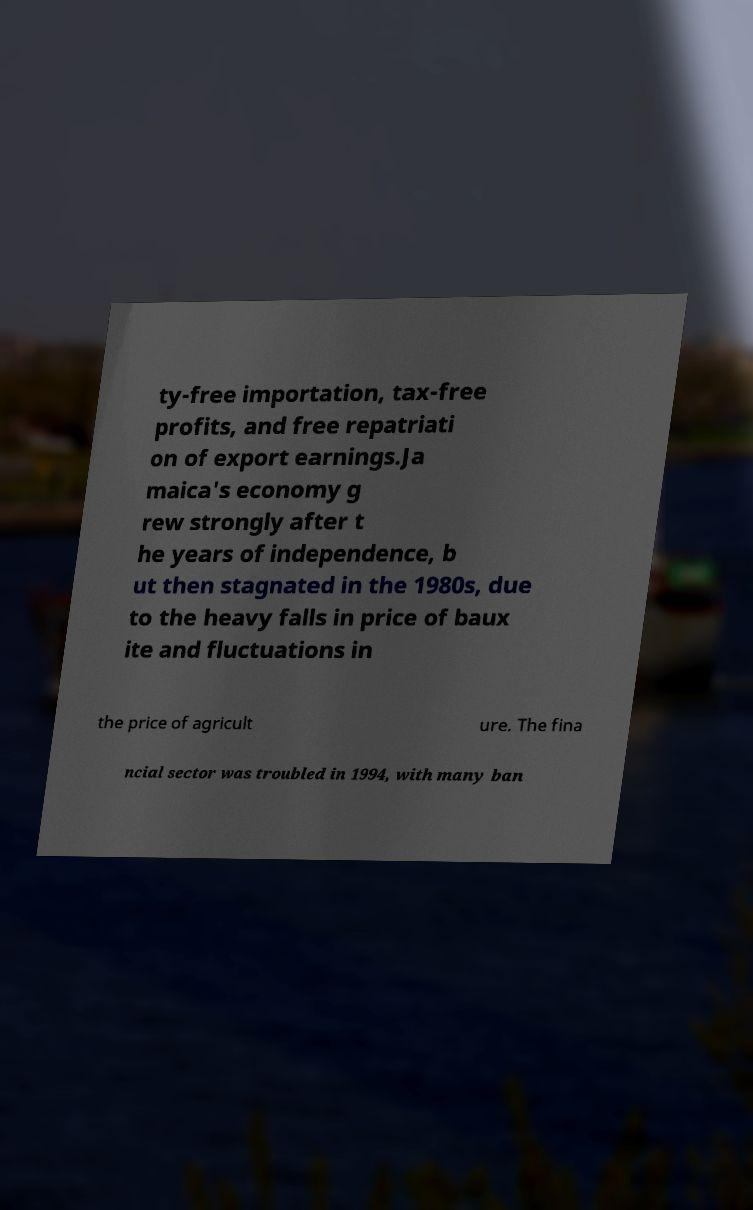What messages or text are displayed in this image? I need them in a readable, typed format. ty-free importation, tax-free profits, and free repatriati on of export earnings.Ja maica's economy g rew strongly after t he years of independence, b ut then stagnated in the 1980s, due to the heavy falls in price of baux ite and fluctuations in the price of agricult ure. The fina ncial sector was troubled in 1994, with many ban 